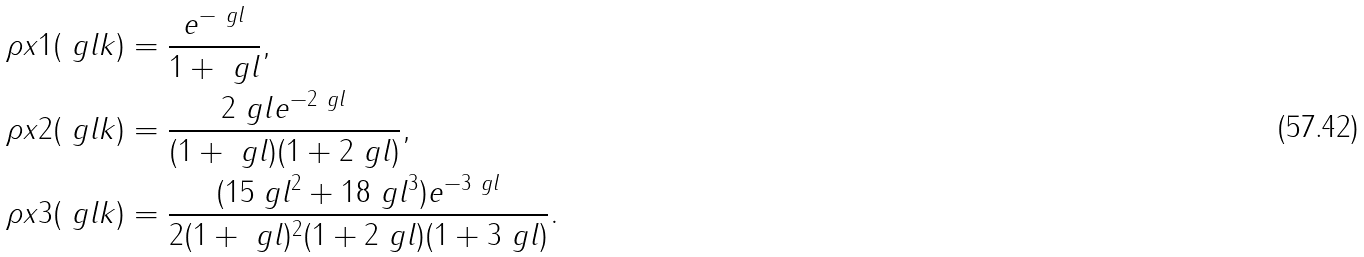Convert formula to latex. <formula><loc_0><loc_0><loc_500><loc_500>\rho x 1 ( \ g l k ) & = \frac { e ^ { - \ g l } } { 1 + \ g l } , \\ \rho x 2 ( \ g l k ) & = \frac { 2 \ g l e ^ { - 2 \ g l } } { ( 1 + \ g l ) ( 1 + 2 \ g l ) } , \\ \rho x 3 ( \ g l k ) & = \frac { ( 1 5 \ g l ^ { 2 } + 1 8 \ g l ^ { 3 } ) e ^ { - 3 \ g l } } { 2 ( 1 + \ g l ) ^ { 2 } ( 1 + 2 \ g l ) ( 1 + 3 \ g l ) } .</formula> 